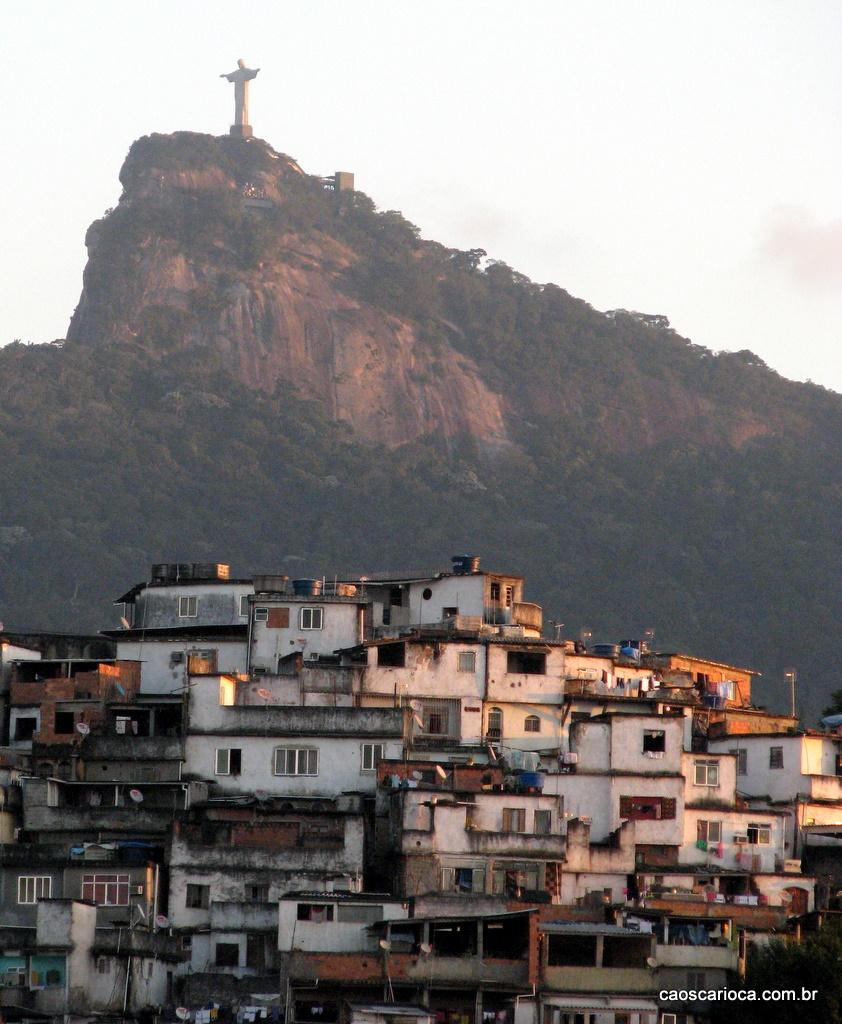What type of structures are visible in the image? There are buildings with windows in the image. What else can be seen in the image besides the buildings? There are objects, trees, a mountain, and a statue in the background of the image. What is visible in the sky in the image? The sky is visible in the background of the image. What type of church can be seen in the image? There is no church present in the image. How far can the statue stretch its arms in the image? The statue does not have arms, and even if it did, we cannot determine how far they could stretch based on the image. 